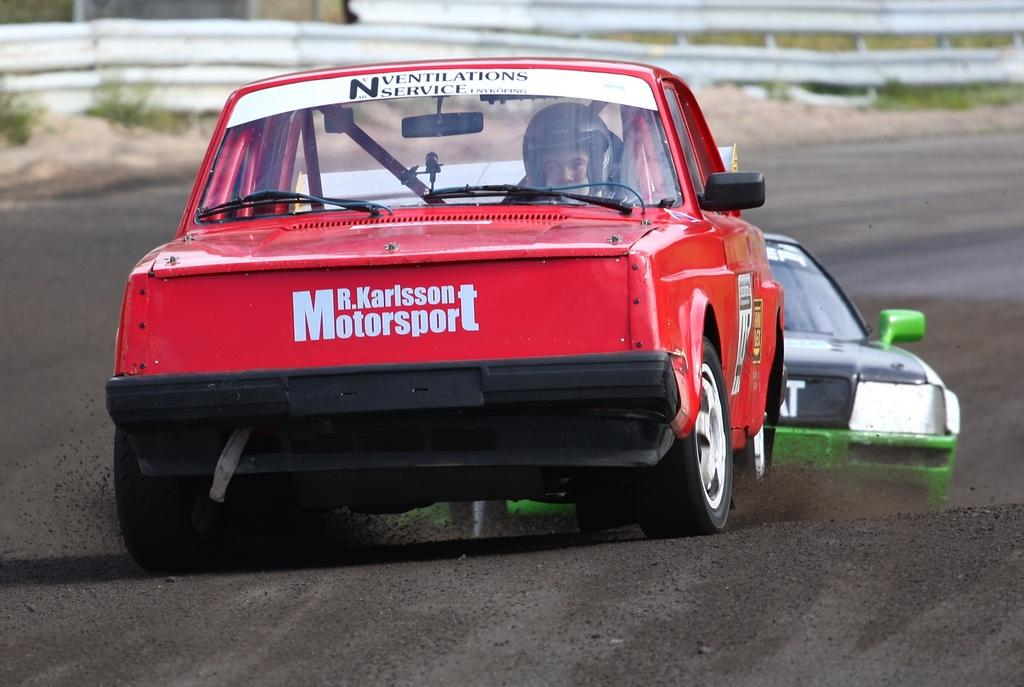What are the people in the image doing? The people in the image are driving a car. Where is the car located in the image? The car is on the road. What can be seen on the left side of the image? There are plants on the left side of the image. What type of instrument is being played by the driver in the image? There is no instrument being played in the image; the people are driving a car. What is the speed limit of the car in the image? The speed limit cannot be determined from the image alone, as it depends on the specific road and location. 